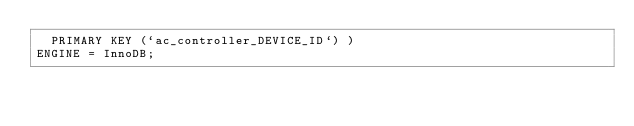<code> <loc_0><loc_0><loc_500><loc_500><_SQL_>  PRIMARY KEY (`ac_controller_DEVICE_ID`) )
ENGINE = InnoDB;




</code> 